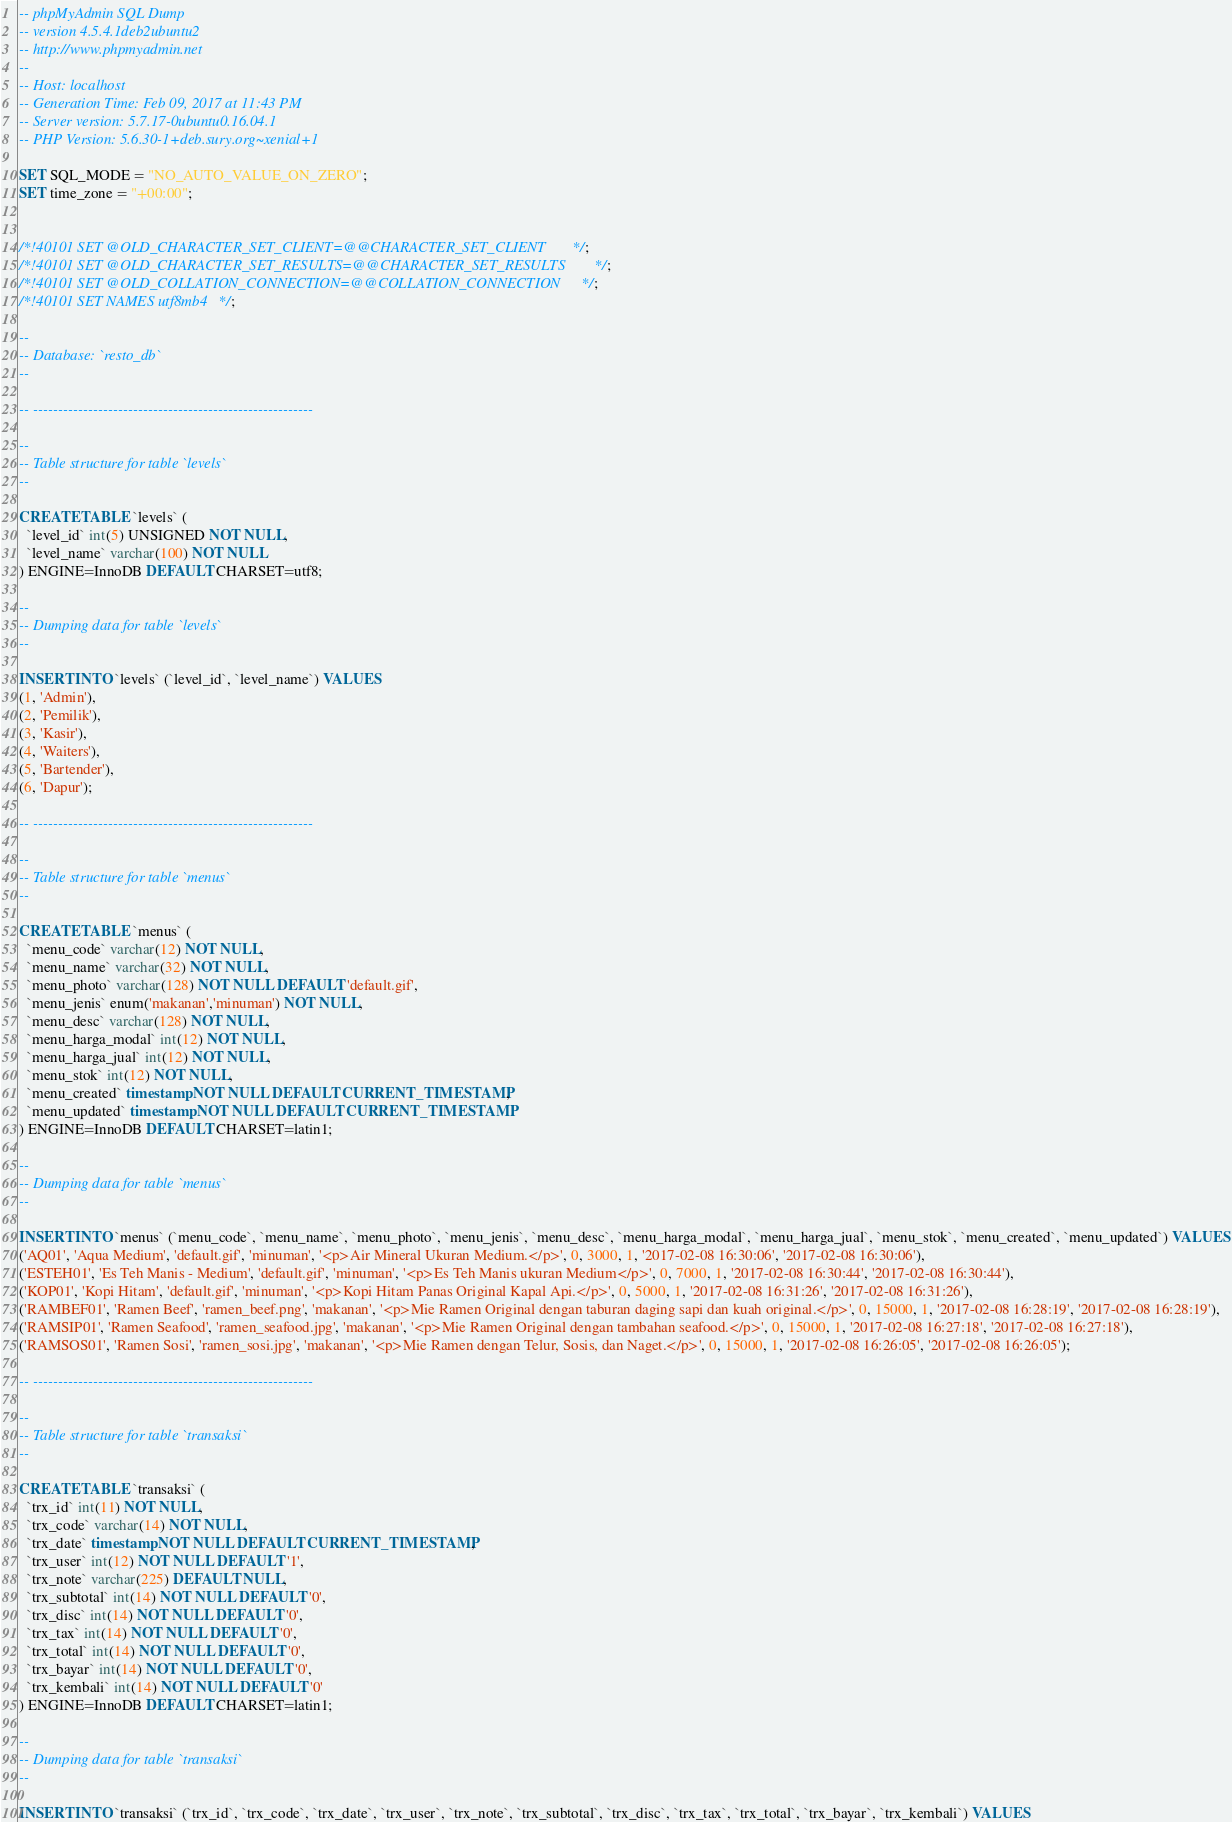<code> <loc_0><loc_0><loc_500><loc_500><_SQL_>-- phpMyAdmin SQL Dump
-- version 4.5.4.1deb2ubuntu2
-- http://www.phpmyadmin.net
--
-- Host: localhost
-- Generation Time: Feb 09, 2017 at 11:43 PM
-- Server version: 5.7.17-0ubuntu0.16.04.1
-- PHP Version: 5.6.30-1+deb.sury.org~xenial+1

SET SQL_MODE = "NO_AUTO_VALUE_ON_ZERO";
SET time_zone = "+00:00";


/*!40101 SET @OLD_CHARACTER_SET_CLIENT=@@CHARACTER_SET_CLIENT */;
/*!40101 SET @OLD_CHARACTER_SET_RESULTS=@@CHARACTER_SET_RESULTS */;
/*!40101 SET @OLD_COLLATION_CONNECTION=@@COLLATION_CONNECTION */;
/*!40101 SET NAMES utf8mb4 */;

--
-- Database: `resto_db`
--

-- --------------------------------------------------------

--
-- Table structure for table `levels`
--

CREATE TABLE `levels` (
  `level_id` int(5) UNSIGNED NOT NULL,
  `level_name` varchar(100) NOT NULL
) ENGINE=InnoDB DEFAULT CHARSET=utf8;

--
-- Dumping data for table `levels`
--

INSERT INTO `levels` (`level_id`, `level_name`) VALUES
(1, 'Admin'),
(2, 'Pemilik'),
(3, 'Kasir'),
(4, 'Waiters'),
(5, 'Bartender'),
(6, 'Dapur');

-- --------------------------------------------------------

--
-- Table structure for table `menus`
--

CREATE TABLE `menus` (
  `menu_code` varchar(12) NOT NULL,
  `menu_name` varchar(32) NOT NULL,
  `menu_photo` varchar(128) NOT NULL DEFAULT 'default.gif',
  `menu_jenis` enum('makanan','minuman') NOT NULL,
  `menu_desc` varchar(128) NOT NULL,
  `menu_harga_modal` int(12) NOT NULL,
  `menu_harga_jual` int(12) NOT NULL,
  `menu_stok` int(12) NOT NULL,
  `menu_created` timestamp NOT NULL DEFAULT CURRENT_TIMESTAMP,
  `menu_updated` timestamp NOT NULL DEFAULT CURRENT_TIMESTAMP
) ENGINE=InnoDB DEFAULT CHARSET=latin1;

--
-- Dumping data for table `menus`
--

INSERT INTO `menus` (`menu_code`, `menu_name`, `menu_photo`, `menu_jenis`, `menu_desc`, `menu_harga_modal`, `menu_harga_jual`, `menu_stok`, `menu_created`, `menu_updated`) VALUES
('AQ01', 'Aqua Medium', 'default.gif', 'minuman', '<p>Air Mineral Ukuran Medium.</p>', 0, 3000, 1, '2017-02-08 16:30:06', '2017-02-08 16:30:06'),
('ESTEH01', 'Es Teh Manis - Medium', 'default.gif', 'minuman', '<p>Es Teh Manis ukuran Medium</p>', 0, 7000, 1, '2017-02-08 16:30:44', '2017-02-08 16:30:44'),
('KOP01', 'Kopi Hitam', 'default.gif', 'minuman', '<p>Kopi Hitam Panas Original Kapal Api.</p>', 0, 5000, 1, '2017-02-08 16:31:26', '2017-02-08 16:31:26'),
('RAMBEF01', 'Ramen Beef', 'ramen_beef.png', 'makanan', '<p>Mie Ramen Original dengan taburan daging sapi dan kuah original.</p>', 0, 15000, 1, '2017-02-08 16:28:19', '2017-02-08 16:28:19'),
('RAMSIP01', 'Ramen Seafood', 'ramen_seafood.jpg', 'makanan', '<p>Mie Ramen Original dengan tambahan seafood.</p>', 0, 15000, 1, '2017-02-08 16:27:18', '2017-02-08 16:27:18'),
('RAMSOS01', 'Ramen Sosi', 'ramen_sosi.jpg', 'makanan', '<p>Mie Ramen dengan Telur, Sosis, dan Naget.</p>', 0, 15000, 1, '2017-02-08 16:26:05', '2017-02-08 16:26:05');

-- --------------------------------------------------------

--
-- Table structure for table `transaksi`
--

CREATE TABLE `transaksi` (
  `trx_id` int(11) NOT NULL,
  `trx_code` varchar(14) NOT NULL,
  `trx_date` timestamp NOT NULL DEFAULT CURRENT_TIMESTAMP,
  `trx_user` int(12) NOT NULL DEFAULT '1',
  `trx_note` varchar(225) DEFAULT NULL,
  `trx_subtotal` int(14) NOT NULL DEFAULT '0',
  `trx_disc` int(14) NOT NULL DEFAULT '0',
  `trx_tax` int(14) NOT NULL DEFAULT '0',
  `trx_total` int(14) NOT NULL DEFAULT '0',
  `trx_bayar` int(14) NOT NULL DEFAULT '0',
  `trx_kembali` int(14) NOT NULL DEFAULT '0'
) ENGINE=InnoDB DEFAULT CHARSET=latin1;

--
-- Dumping data for table `transaksi`
--

INSERT INTO `transaksi` (`trx_id`, `trx_code`, `trx_date`, `trx_user`, `trx_note`, `trx_subtotal`, `trx_disc`, `trx_tax`, `trx_total`, `trx_bayar`, `trx_kembali`) VALUES</code> 